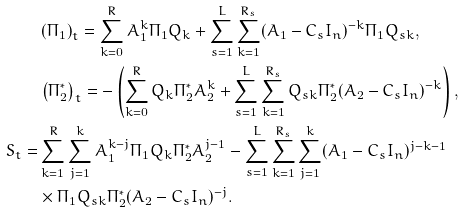Convert formula to latex. <formula><loc_0><loc_0><loc_500><loc_500>& \left ( \Pi _ { 1 } \right ) _ { t } = \sum _ { k = 0 } ^ { R } A _ { 1 } ^ { k } \Pi _ { 1 } Q _ { k } + \sum _ { s = 1 } ^ { L } \sum _ { k = 1 } ^ { R _ { s } } ( A _ { 1 } - C _ { s } I _ { n } ) ^ { - k } \Pi _ { 1 } Q _ { s k } , \\ & \left ( \Pi _ { 2 } ^ { * } \right ) _ { t } = - \left ( \sum _ { k = 0 } ^ { R } Q _ { k } \Pi _ { 2 } ^ { * } A _ { 2 } ^ { k } + \sum _ { s = 1 } ^ { L } \sum _ { k = 1 } ^ { R _ { s } } Q _ { s k } \Pi _ { 2 } ^ { * } ( A _ { 2 } - C _ { s } I _ { n } ) ^ { - k } \right ) , \\ S _ { t } = & \sum _ { k = 1 } ^ { R } \sum _ { j = 1 } ^ { k } A _ { 1 } ^ { k - j } \Pi _ { 1 } Q _ { k } \Pi _ { 2 } ^ { * } A _ { 2 } ^ { j - 1 } - \sum _ { s = 1 } ^ { L } \sum _ { k = 1 } ^ { R _ { s } } \sum _ { j = 1 } ^ { k } ( A _ { 1 } - C _ { s } I _ { n } ) ^ { j - k - 1 } \\ & \times \Pi _ { 1 } Q _ { s k } \Pi _ { 2 } ^ { * } ( A _ { 2 } - C _ { s } I _ { n } ) ^ { - j } .</formula> 